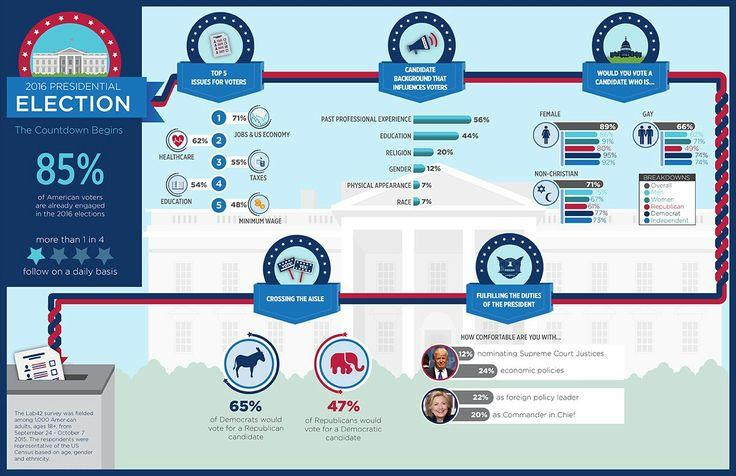Draw attention to some important aspects in this diagram. A majority of 80% of Republican voters would cast their ballot for a female candidate. According to the data, 66% of voters are likely to vote for a gay presidential candidate. According to the data, 32% of voters prefer candidates based on their religion and gender. A majority of people, or 3 out of 4, do not follow the presidential election on a daily basis. A majority of Democrats, or 77%, would vote for a non-Christian candidate. 